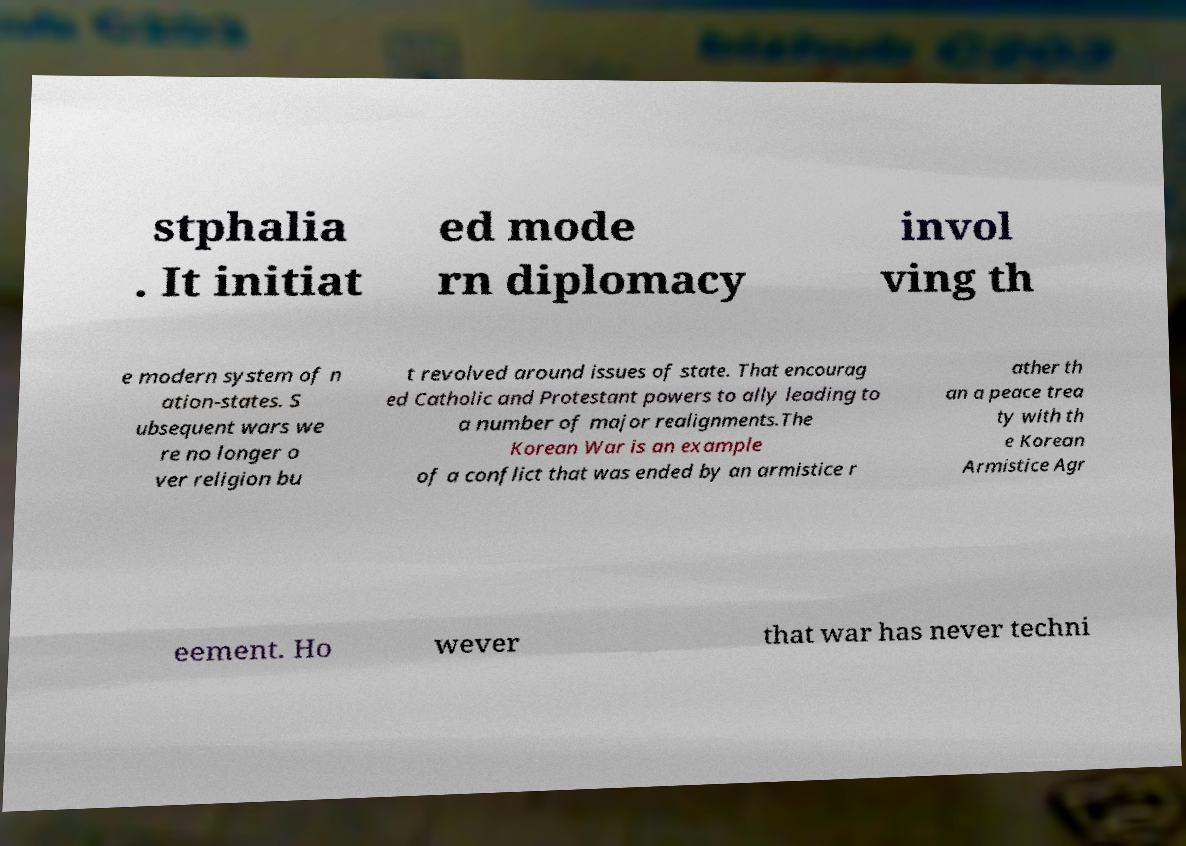Can you read and provide the text displayed in the image?This photo seems to have some interesting text. Can you extract and type it out for me? stphalia . It initiat ed mode rn diplomacy invol ving th e modern system of n ation-states. S ubsequent wars we re no longer o ver religion bu t revolved around issues of state. That encourag ed Catholic and Protestant powers to ally leading to a number of major realignments.The Korean War is an example of a conflict that was ended by an armistice r ather th an a peace trea ty with th e Korean Armistice Agr eement. Ho wever that war has never techni 